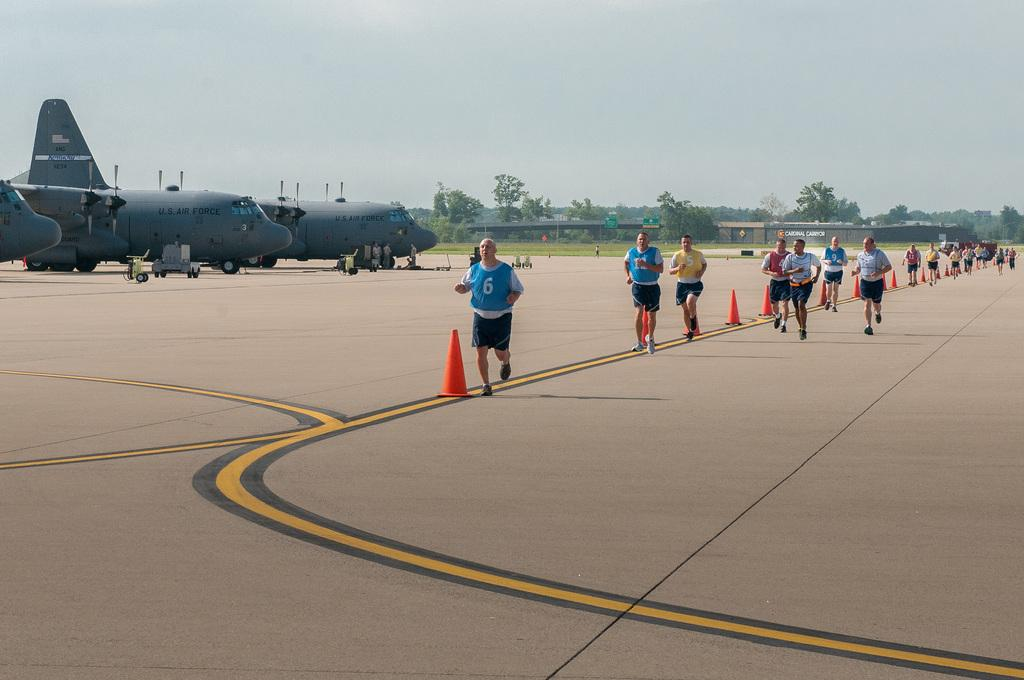<image>
Describe the image concisely. Blue number six jersey and yellow number five jersey. 